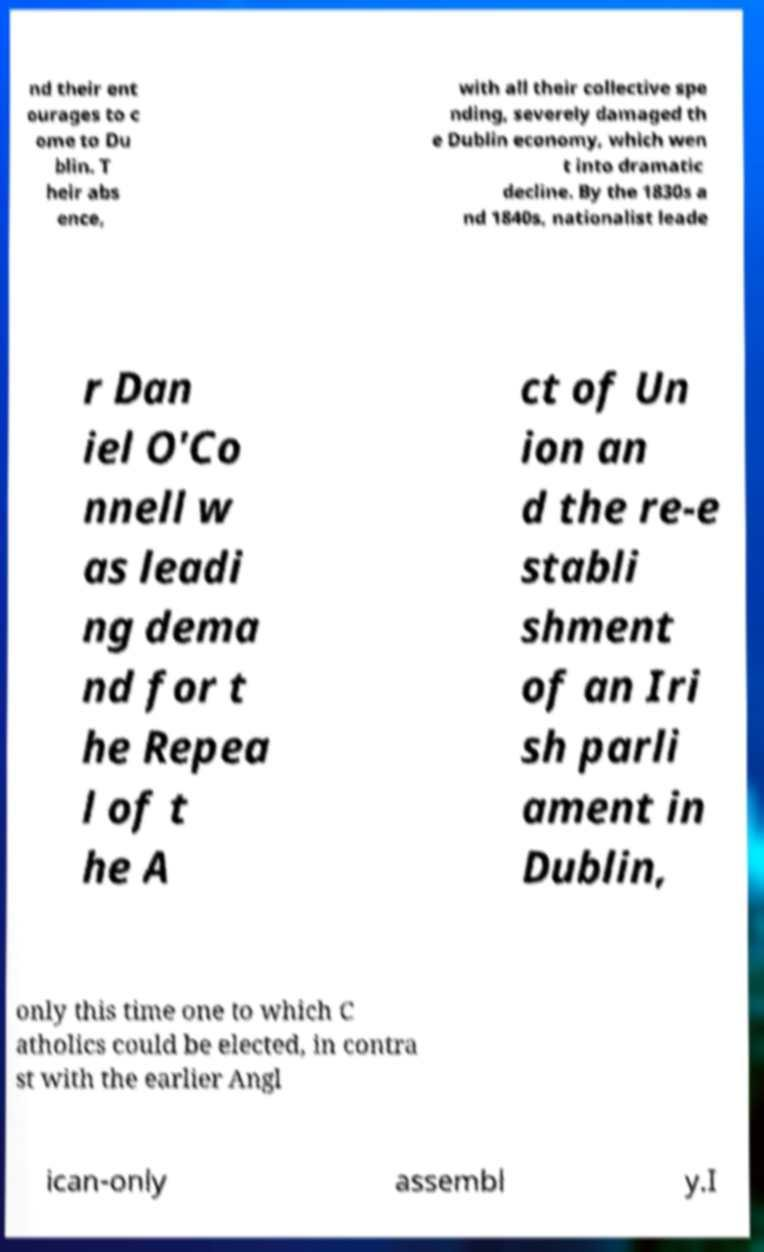I need the written content from this picture converted into text. Can you do that? nd their ent ourages to c ome to Du blin. T heir abs ence, with all their collective spe nding, severely damaged th e Dublin economy, which wen t into dramatic decline. By the 1830s a nd 1840s, nationalist leade r Dan iel O'Co nnell w as leadi ng dema nd for t he Repea l of t he A ct of Un ion an d the re-e stabli shment of an Iri sh parli ament in Dublin, only this time one to which C atholics could be elected, in contra st with the earlier Angl ican-only assembl y.I 